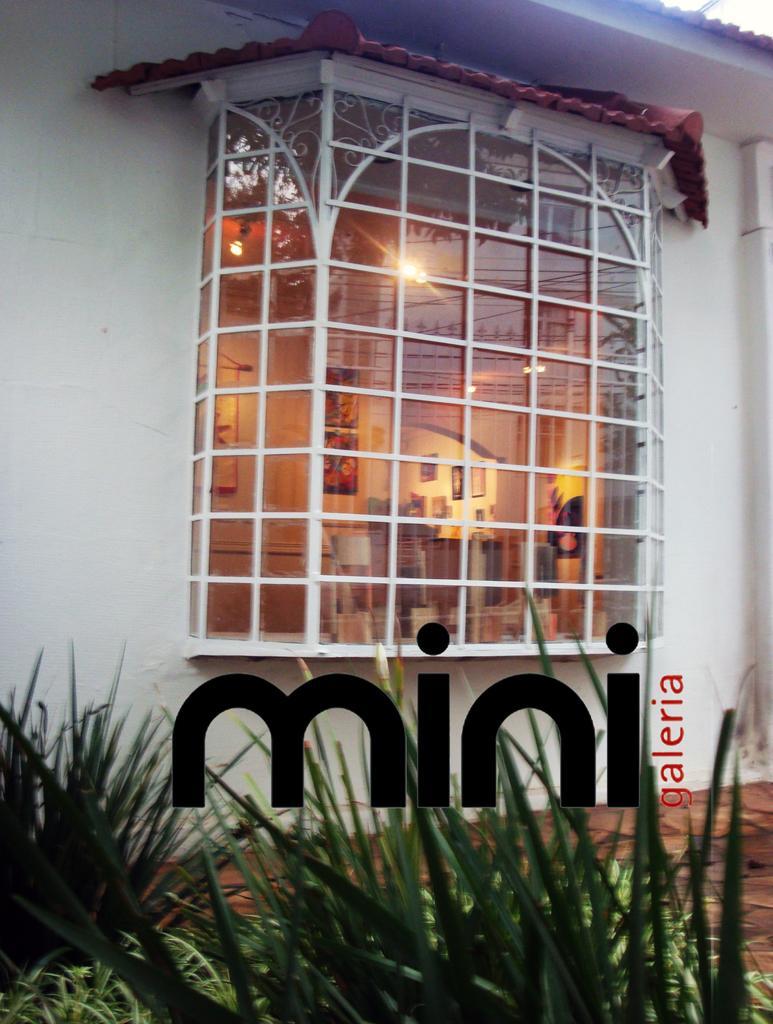Describe this image in one or two sentences. In this image we can see a window, inside the window room is there. The walls are in white color. Bottom of the image plants are there and on the image a watermark is present. 